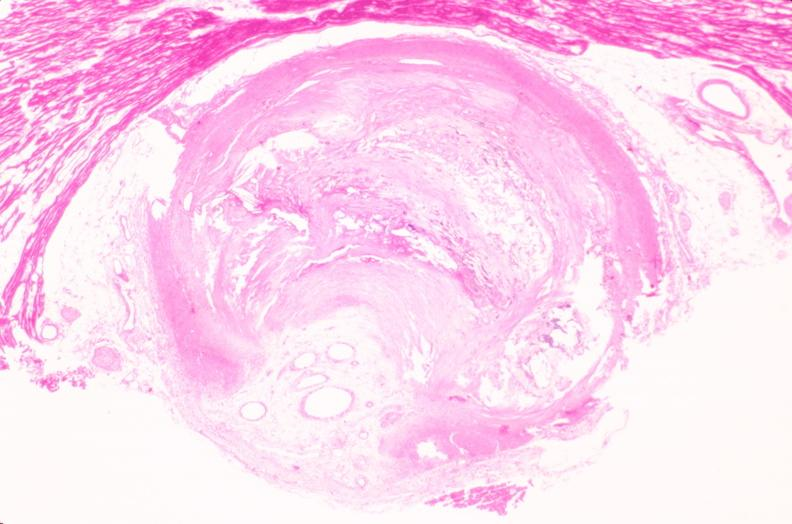s very good example present?
Answer the question using a single word or phrase. No 